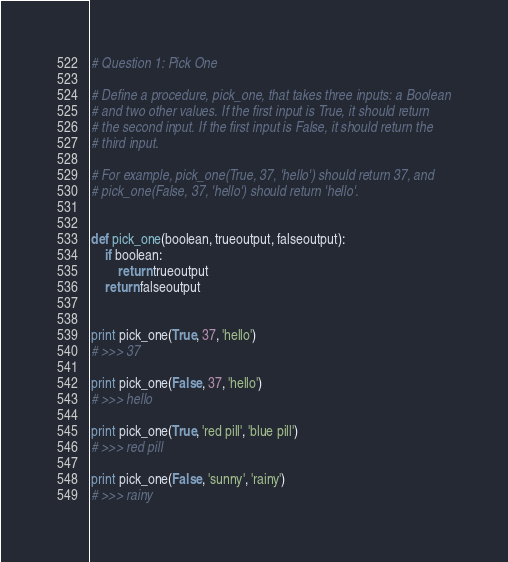<code> <loc_0><loc_0><loc_500><loc_500><_Python_># Question 1: Pick One

# Define a procedure, pick_one, that takes three inputs: a Boolean
# and two other values. If the first input is True, it should return
# the second input. If the first input is False, it should return the
# third input.

# For example, pick_one(True, 37, 'hello') should return 37, and
# pick_one(False, 37, 'hello') should return 'hello'.


def pick_one(boolean, trueoutput, falseoutput):
    if boolean:
        return trueoutput
    return falseoutput


print pick_one(True, 37, 'hello')
# >>> 37

print pick_one(False, 37, 'hello')
# >>> hello

print pick_one(True, 'red pill', 'blue pill')
# >>> red pill

print pick_one(False, 'sunny', 'rainy')
# >>> rainy
</code> 